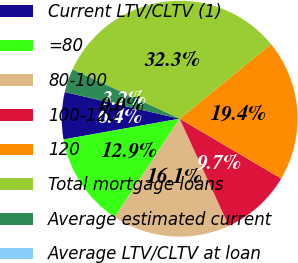<chart> <loc_0><loc_0><loc_500><loc_500><pie_chart><fcel>Current LTV/CLTV (1)<fcel>=80<fcel>80-100<fcel>100-120<fcel>120<fcel>Total mortgage loans<fcel>Average estimated current<fcel>Average LTV/CLTV at loan<nl><fcel>6.45%<fcel>12.9%<fcel>16.13%<fcel>9.68%<fcel>19.35%<fcel>32.26%<fcel>3.23%<fcel>0.0%<nl></chart> 